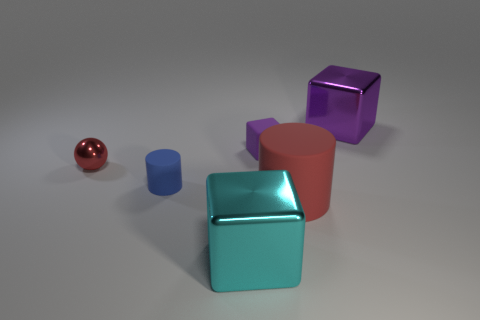Add 2 large gray objects. How many objects exist? 8 Subtract all spheres. How many objects are left? 5 Add 1 big red rubber things. How many big red rubber things exist? 2 Subtract 0 purple cylinders. How many objects are left? 6 Subtract all tiny red metallic things. Subtract all purple matte cylinders. How many objects are left? 5 Add 2 spheres. How many spheres are left? 3 